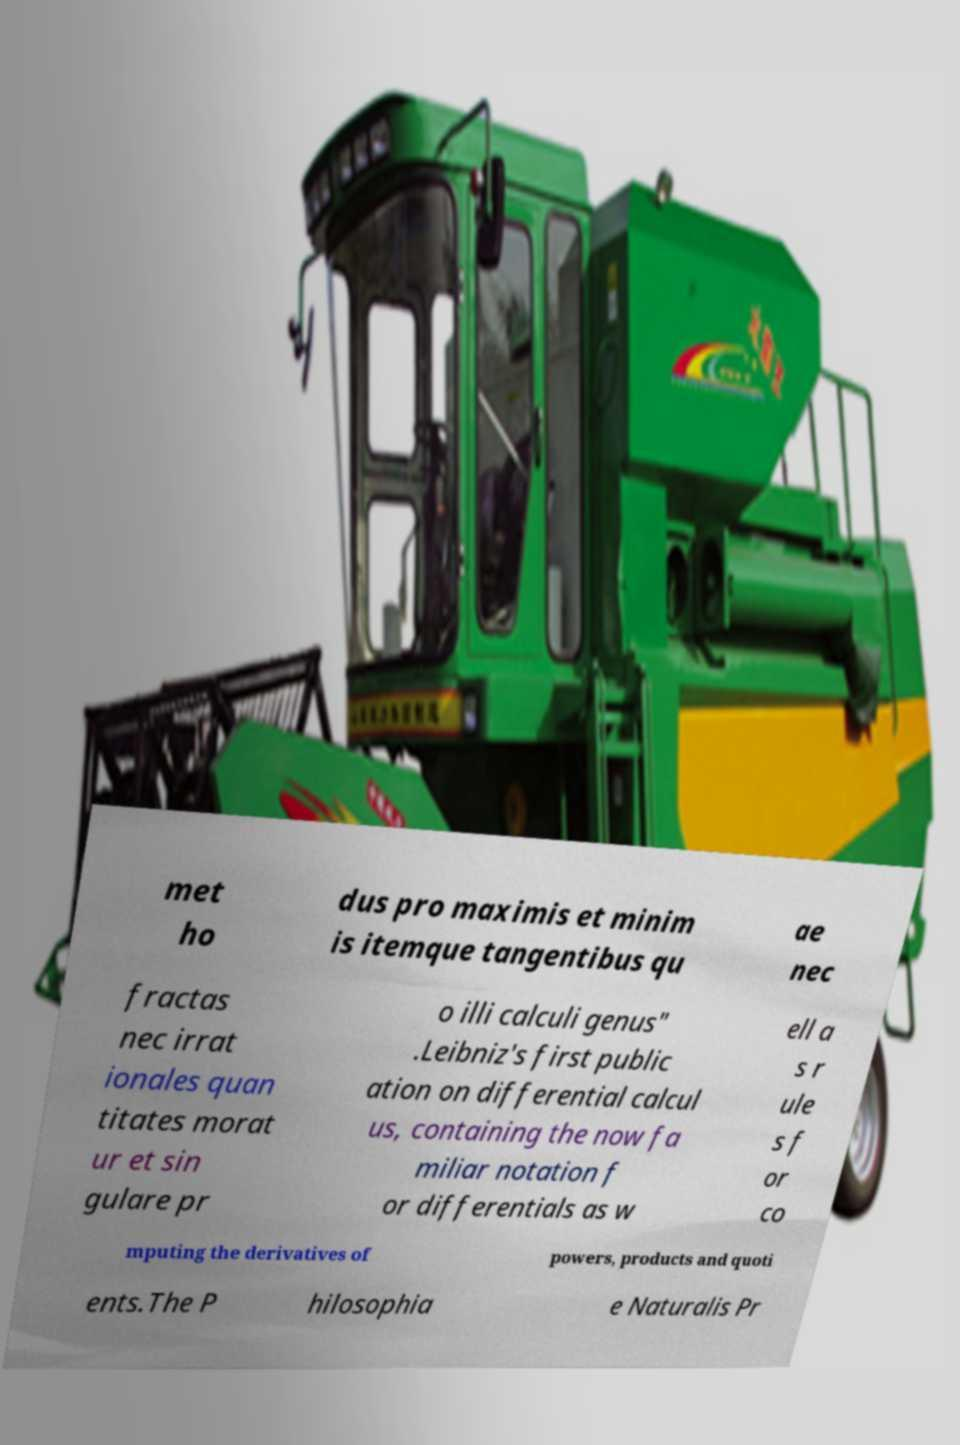There's text embedded in this image that I need extracted. Can you transcribe it verbatim? met ho dus pro maximis et minim is itemque tangentibus qu ae nec fractas nec irrat ionales quan titates morat ur et sin gulare pr o illi calculi genus" .Leibniz's first public ation on differential calcul us, containing the now fa miliar notation f or differentials as w ell a s r ule s f or co mputing the derivatives of powers, products and quoti ents.The P hilosophia e Naturalis Pr 